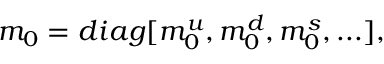Convert formula to latex. <formula><loc_0><loc_0><loc_500><loc_500>m _ { 0 } = d i a g [ m _ { 0 } ^ { u } , m _ { 0 } ^ { d } , m _ { 0 } ^ { s } , \dots ] ,</formula> 